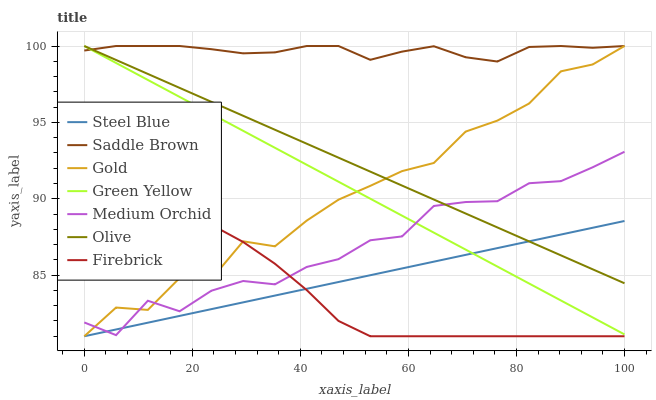Does Firebrick have the minimum area under the curve?
Answer yes or no. Yes. Does Saddle Brown have the maximum area under the curve?
Answer yes or no. Yes. Does Medium Orchid have the minimum area under the curve?
Answer yes or no. No. Does Medium Orchid have the maximum area under the curve?
Answer yes or no. No. Is Olive the smoothest?
Answer yes or no. Yes. Is Gold the roughest?
Answer yes or no. Yes. Is Firebrick the smoothest?
Answer yes or no. No. Is Firebrick the roughest?
Answer yes or no. No. Does Medium Orchid have the lowest value?
Answer yes or no. No. Does Firebrick have the highest value?
Answer yes or no. No. Is Medium Orchid less than Saddle Brown?
Answer yes or no. Yes. Is Saddle Brown greater than Steel Blue?
Answer yes or no. Yes. Does Medium Orchid intersect Saddle Brown?
Answer yes or no. No. 